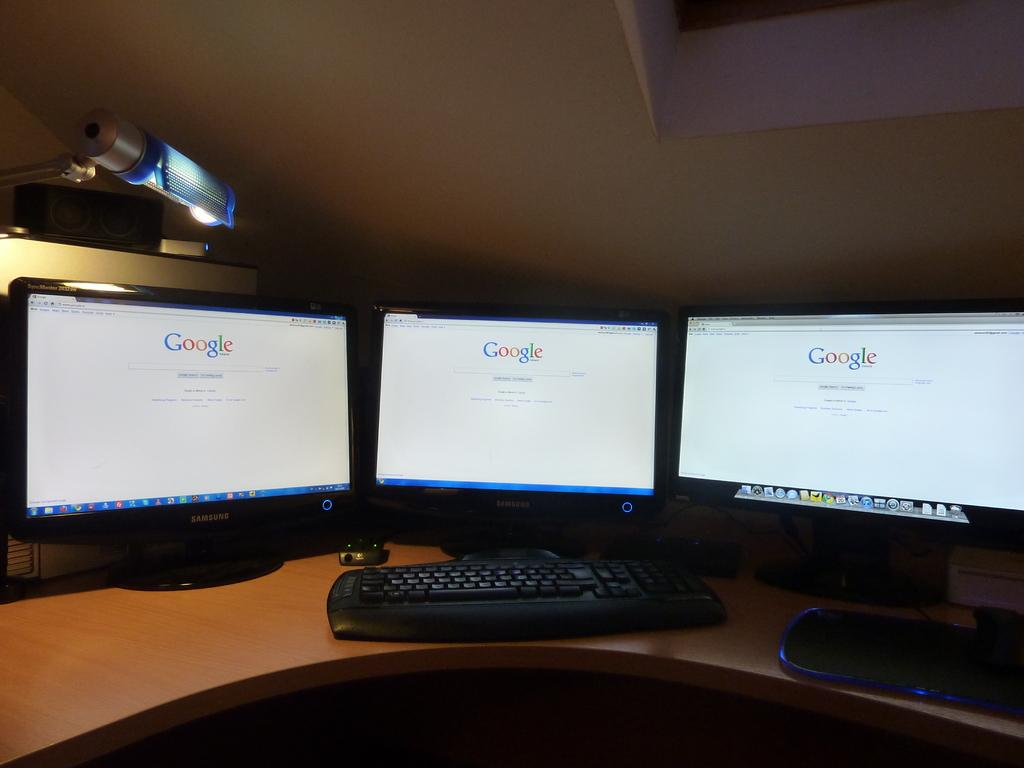<image>
Share a concise interpretation of the image provided. Three computer monitors placed next to each other are opened to Google. 